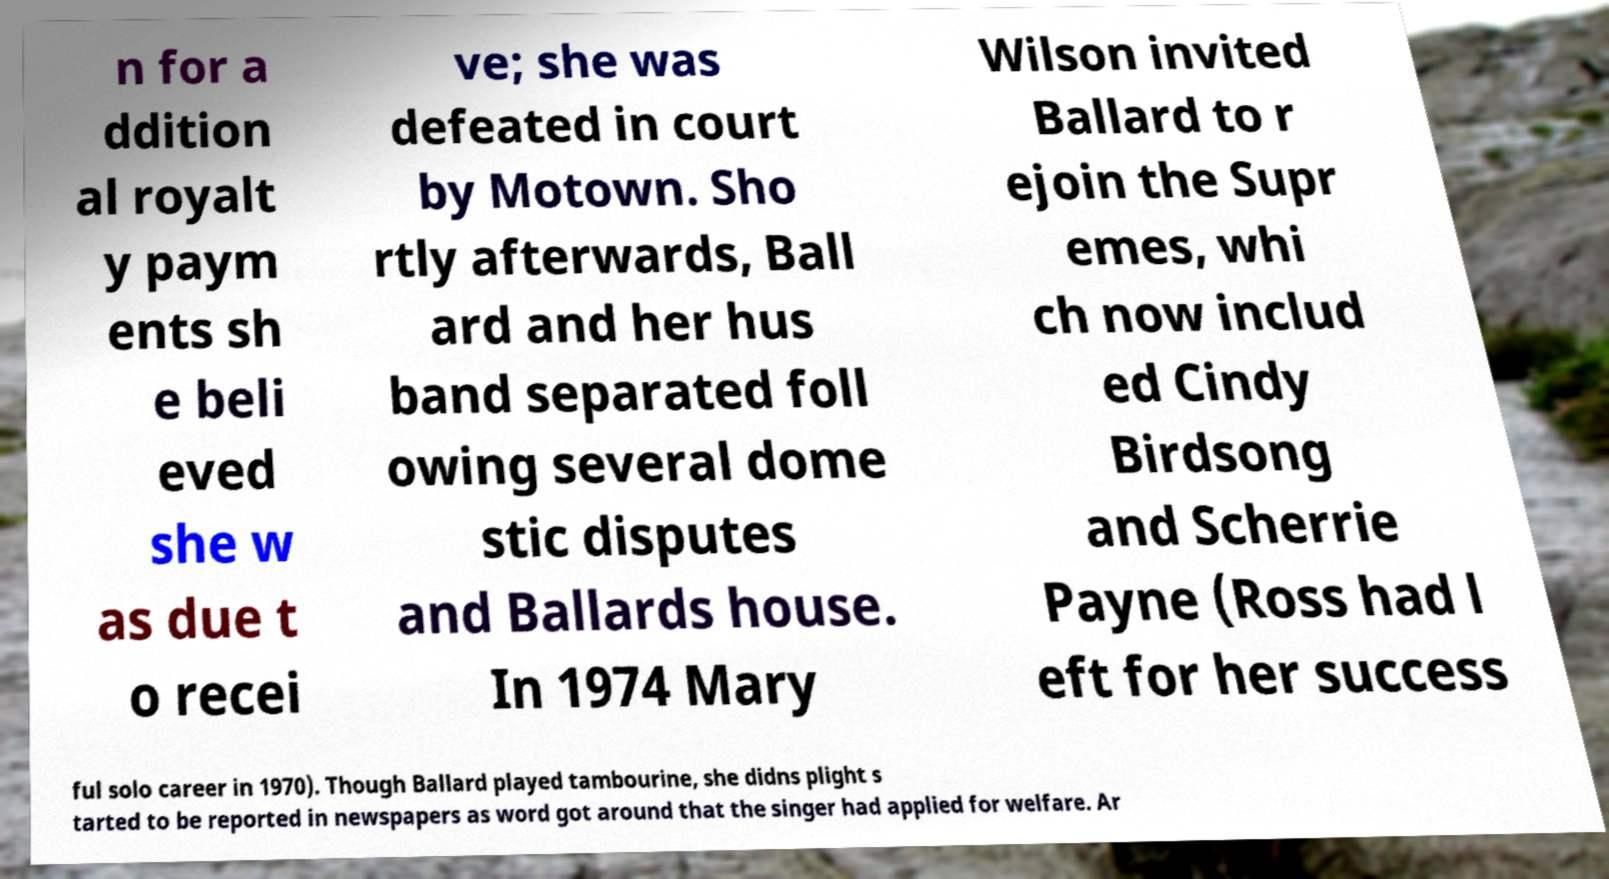What messages or text are displayed in this image? I need them in a readable, typed format. n for a ddition al royalt y paym ents sh e beli eved she w as due t o recei ve; she was defeated in court by Motown. Sho rtly afterwards, Ball ard and her hus band separated foll owing several dome stic disputes and Ballards house. In 1974 Mary Wilson invited Ballard to r ejoin the Supr emes, whi ch now includ ed Cindy Birdsong and Scherrie Payne (Ross had l eft for her success ful solo career in 1970). Though Ballard played tambourine, she didns plight s tarted to be reported in newspapers as word got around that the singer had applied for welfare. Ar 